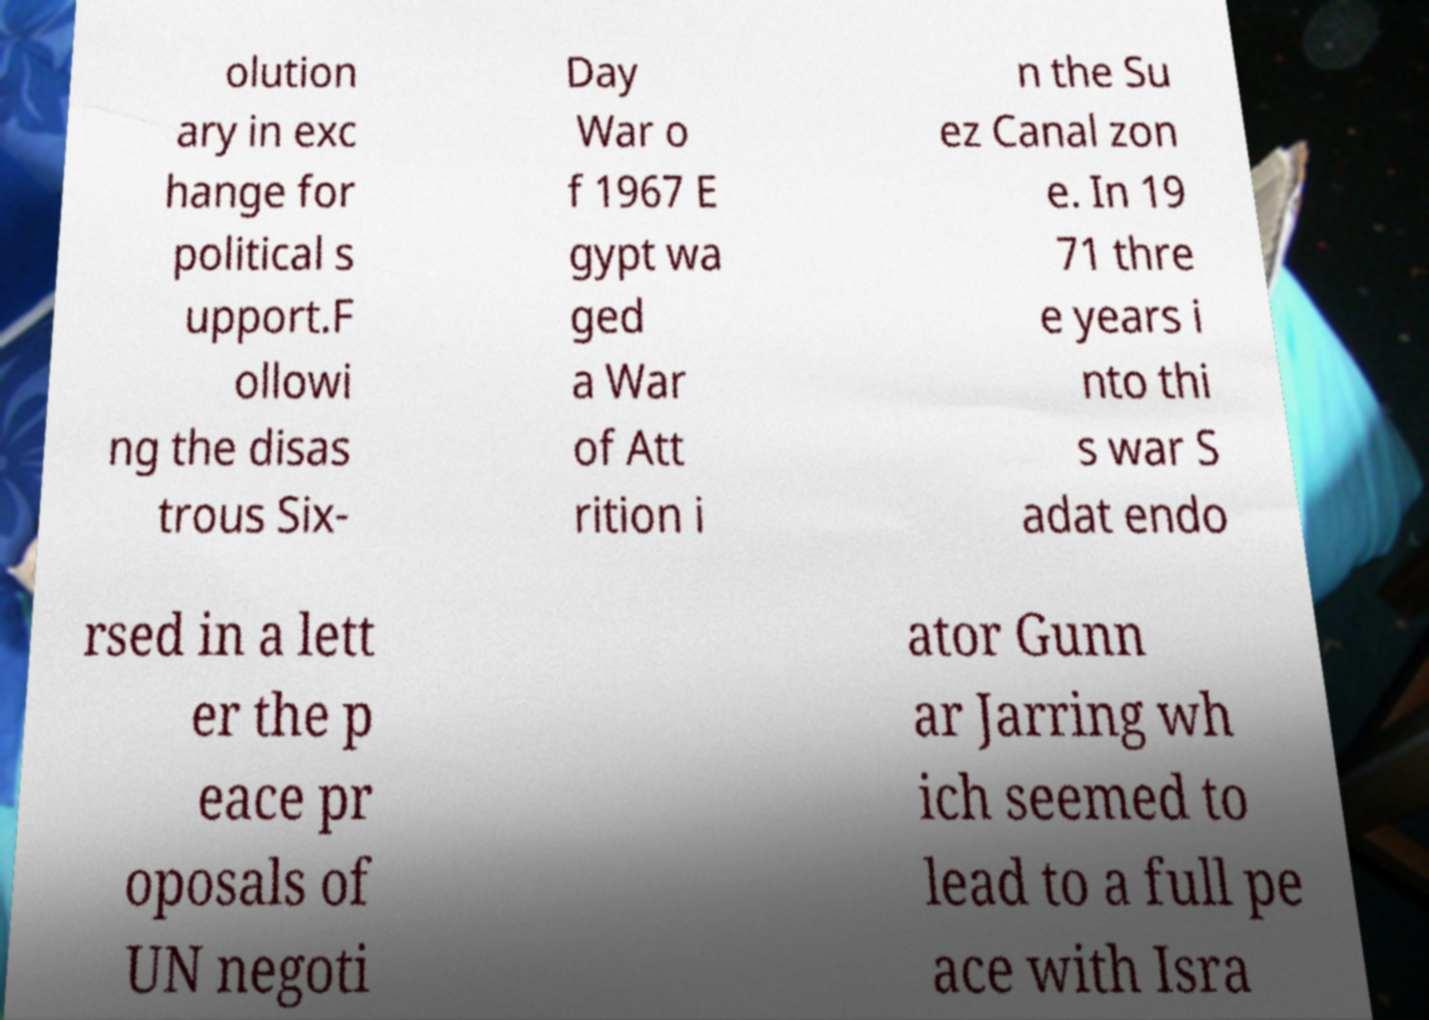For documentation purposes, I need the text within this image transcribed. Could you provide that? olution ary in exc hange for political s upport.F ollowi ng the disas trous Six- Day War o f 1967 E gypt wa ged a War of Att rition i n the Su ez Canal zon e. In 19 71 thre e years i nto thi s war S adat endo rsed in a lett er the p eace pr oposals of UN negoti ator Gunn ar Jarring wh ich seemed to lead to a full pe ace with Isra 